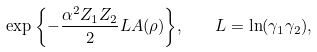Convert formula to latex. <formula><loc_0><loc_0><loc_500><loc_500>\exp { \left \{ - \frac { \alpha ^ { 2 } Z _ { 1 } Z _ { 2 } } { 2 } L A ( \rho ) \right \} } , \quad L = \ln ( \gamma _ { 1 } \gamma _ { 2 } ) ,</formula> 